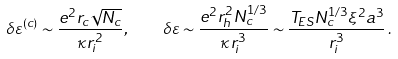<formula> <loc_0><loc_0><loc_500><loc_500>\delta \varepsilon ^ { ( c ) } \sim \frac { e ^ { 2 } r _ { c } \sqrt { N _ { c } } } { \kappa r _ { i } ^ { 2 } } , \quad \delta \varepsilon \sim \frac { e ^ { 2 } r _ { h } ^ { 2 } N _ { c } ^ { 1 / 3 } } { \kappa r _ { i } ^ { 3 } } \sim \frac { T _ { E S } N _ { c } ^ { 1 / 3 } \xi ^ { 2 } a ^ { 3 } } { r _ { i } ^ { 3 } } \, .</formula> 